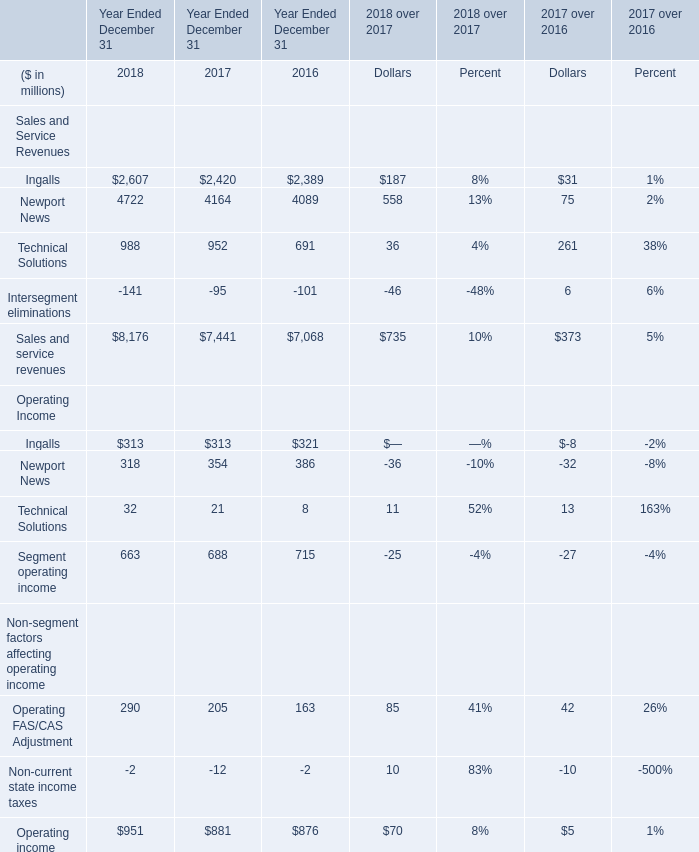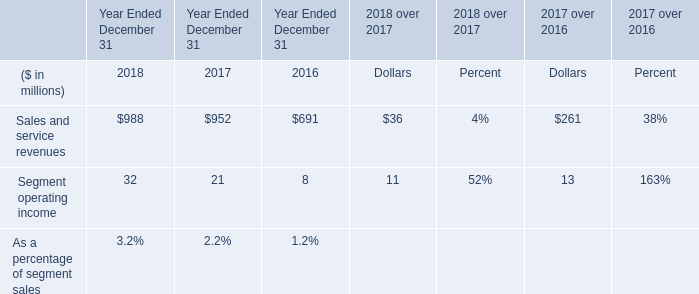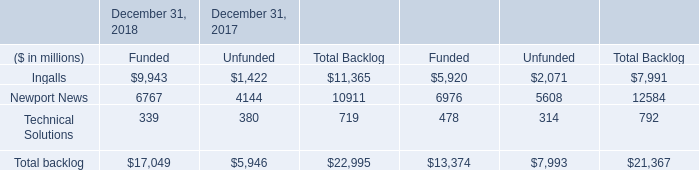If Technical Solutions for Sales and Service Revenues develops with the same increasing rate in 2017, what will it reach in 2018? (in million) 
Computations: ((1 + ((952 - 691) / 691)) * 952)
Answer: 1311.58321. 